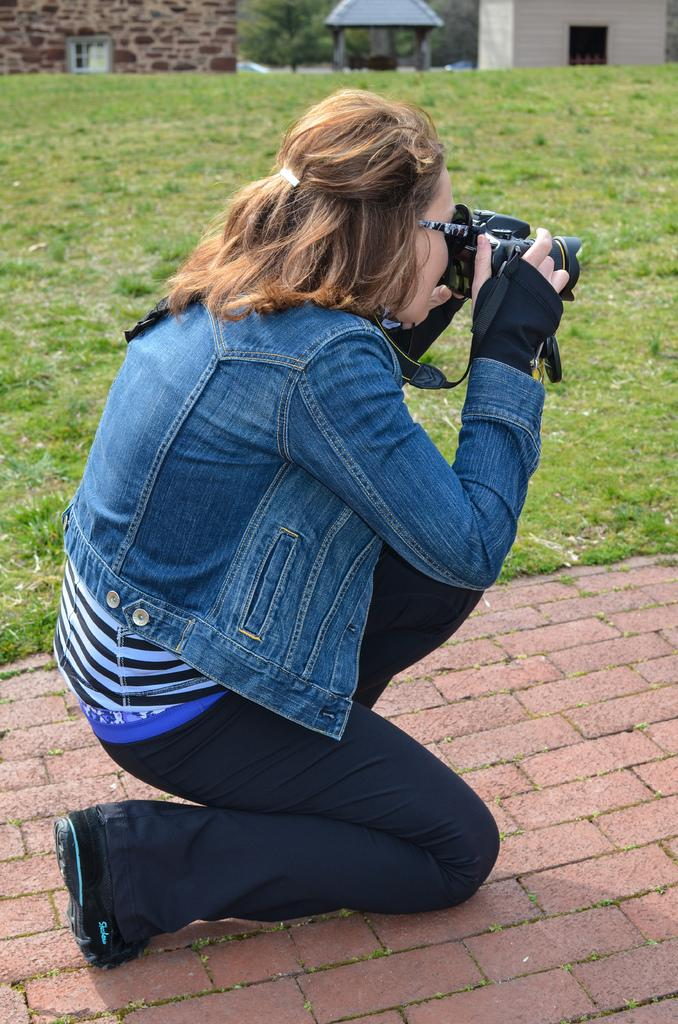Who is the main subject in the image? There is a woman in the image. What is the woman holding in her hand? The woman is holding a camera in her hand. Where is the woman located in the image? The woman is on a path. What type of landscape is visible behind the woman? There is grassland behind the woman. What structures can be seen in the top part of the image? There are buildings visible in the top part of the image. What type of vegetation is present near the buildings? There is a tree behind the buildings. How many coaches can be seen in the image? There are no coaches present in the image. What type of footwear is the woman wearing in the image? The image does not show the woman's footwear, so it cannot be determined from the image. 